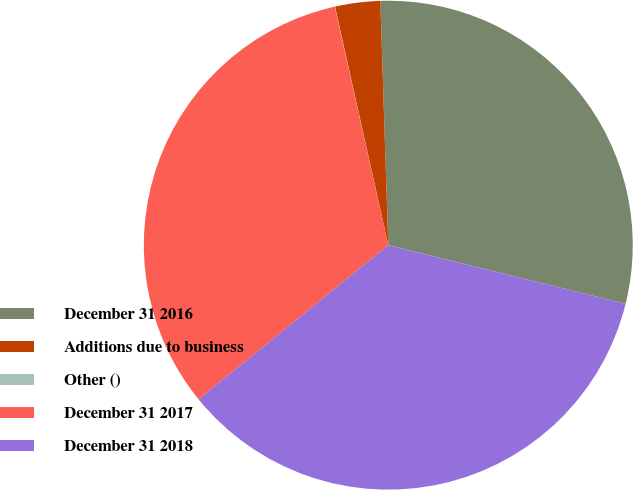Convert chart. <chart><loc_0><loc_0><loc_500><loc_500><pie_chart><fcel>December 31 2016<fcel>Additions due to business<fcel>Other ()<fcel>December 31 2017<fcel>December 31 2018<nl><fcel>29.37%<fcel>2.98%<fcel>0.02%<fcel>32.33%<fcel>35.29%<nl></chart> 